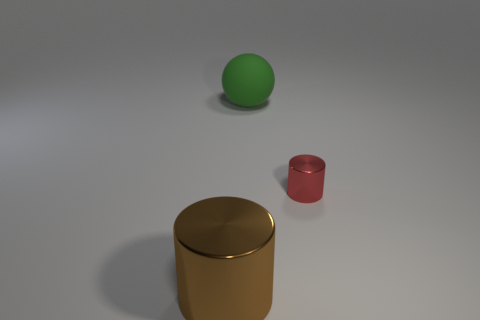What is the thing that is both in front of the big matte thing and to the left of the small object made of? metal 